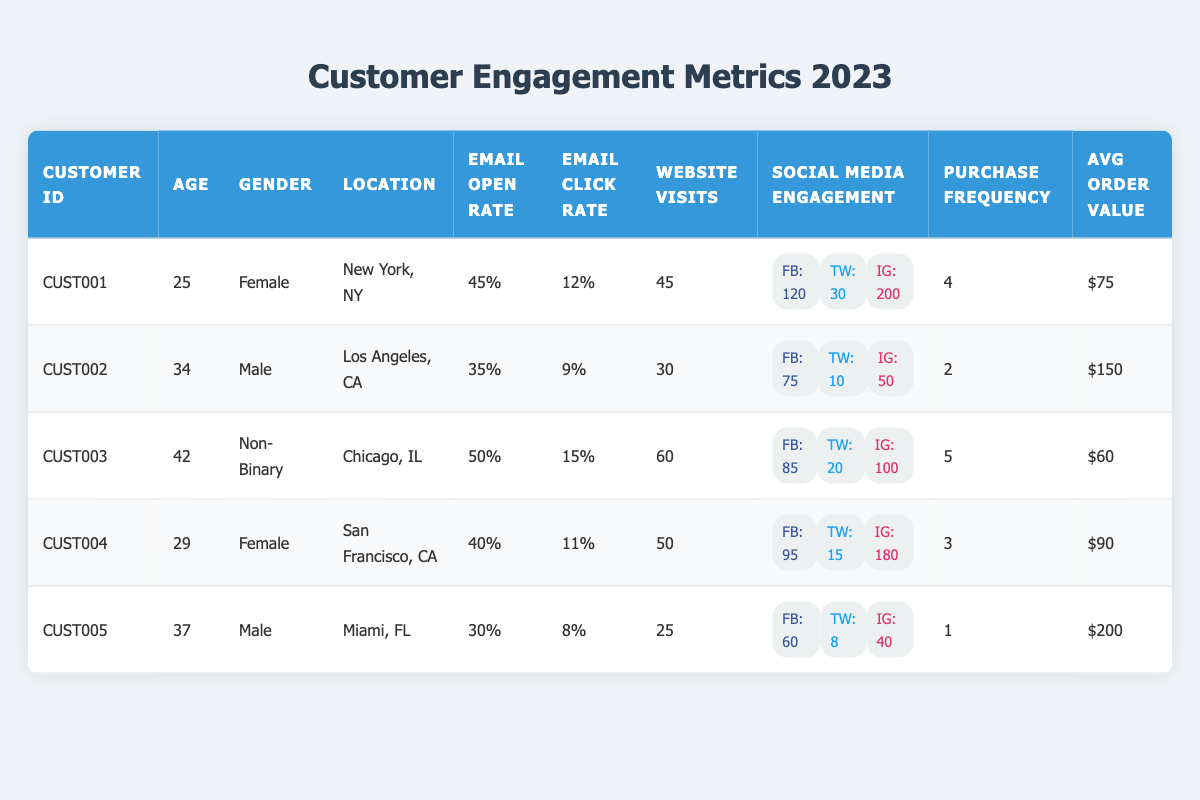What is the email open rate for the customer with ID CUST003? By checking the row for CUST003, the email open rate is listed as 50%.
Answer: 50% Which customer has the highest average order value? A comparison of the average order values shows that CUST005 has the highest value at $200.
Answer: CUST005 How many total website visits were recorded across all customers? Adding the website visits from each row: (45 + 30 + 60 + 50 + 25) = 210.
Answer: 210 What is the purchase frequency of the female customers on average? The female customers are CUST001 and CUST004. Their purchase frequencies are 4 and 3 respectively. Average = (4 + 3)/2 = 3.5.
Answer: 3.5 Which location has customers with the highest email click rates? Checking the email click rates for each customer, the highest is CUST003 with 15% from Chicago, IL.
Answer: Chicago, IL Are there any customers who engaged with over 100 Instagram accounts? Evaluating the Instagram follows, CUST001 (200) and CUST004 (180) both engaged with over 100.
Answer: Yes What is the average age of customers who frequently purchase (defined as those with a purchase frequency of 3 or more)? The customers with 3 or more purchase frequency are CUST001 (25), CUST003 (42), and CUST004 (29). Their average age = (25 + 42 + 29) / 3 = 32.
Answer: 32 Which customer has the lowest email click rate and what is that rate? By examining the table, CUST005 has the lowest email click rate at 8%.
Answer: 8% What is the total number of Facebook likes accumulated by all customers? Summing the Facebook likes: (120 + 75 + 85 + 95 + 60) = 435.
Answer: 435 Is there any customer from Miami, FL who has an email open rate above 30%? CUST005 from Miami, FL has an email open rate of 30%, which does not meet the condition of being above 30%.
Answer: No 